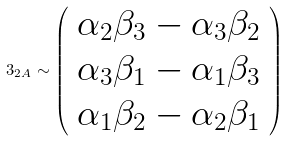<formula> <loc_0><loc_0><loc_500><loc_500>3 _ { 2 A } \sim \left ( \begin{array} { c } \alpha _ { 2 } \beta _ { 3 } - \alpha _ { 3 } \beta _ { 2 } \\ \alpha _ { 3 } \beta _ { 1 } - \alpha _ { 1 } \beta _ { 3 } \\ \alpha _ { 1 } \beta _ { 2 } - \alpha _ { 2 } \beta _ { 1 } \end{array} \right )</formula> 